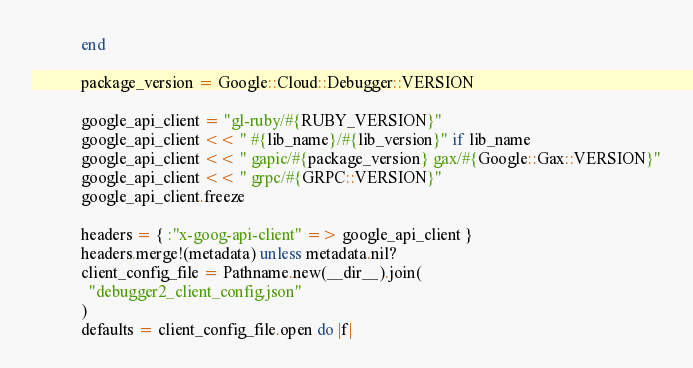Convert code to text. <code><loc_0><loc_0><loc_500><loc_500><_Ruby_>            end

            package_version = Google::Cloud::Debugger::VERSION

            google_api_client = "gl-ruby/#{RUBY_VERSION}"
            google_api_client << " #{lib_name}/#{lib_version}" if lib_name
            google_api_client << " gapic/#{package_version} gax/#{Google::Gax::VERSION}"
            google_api_client << " grpc/#{GRPC::VERSION}"
            google_api_client.freeze

            headers = { :"x-goog-api-client" => google_api_client }
            headers.merge!(metadata) unless metadata.nil?
            client_config_file = Pathname.new(__dir__).join(
              "debugger2_client_config.json"
            )
            defaults = client_config_file.open do |f|</code> 